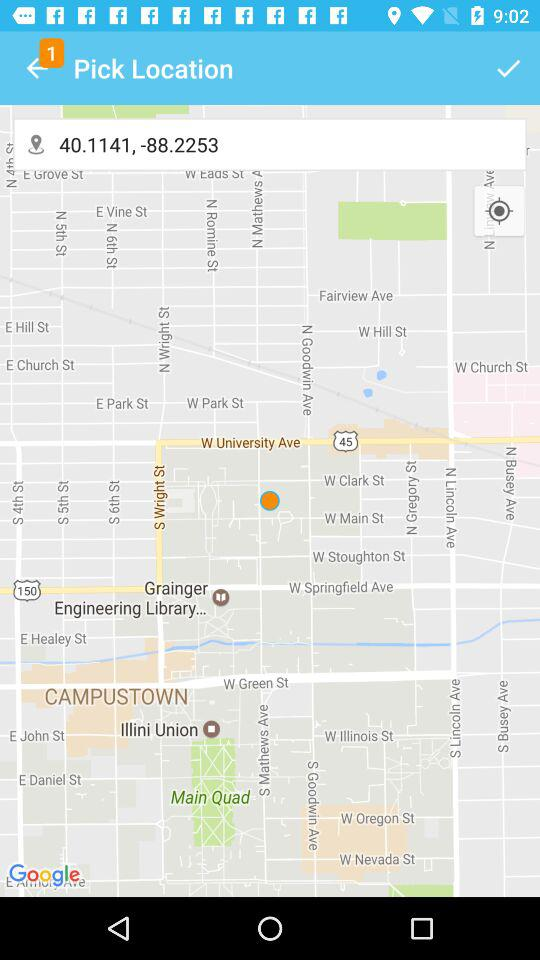What are the latitudes and longitudes? The latitude is 40.1141 and the longitude is -88.2253. 